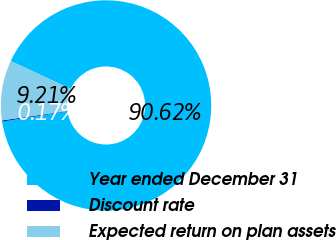Convert chart. <chart><loc_0><loc_0><loc_500><loc_500><pie_chart><fcel>Year ended December 31<fcel>Discount rate<fcel>Expected return on plan assets<nl><fcel>90.62%<fcel>0.17%<fcel>9.21%<nl></chart> 